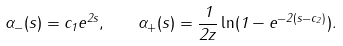<formula> <loc_0><loc_0><loc_500><loc_500>\alpha _ { - } ( s ) = c _ { 1 } e ^ { 2 s } , \quad \alpha _ { + } ( s ) = \frac { 1 } { 2 { z } } \ln ( 1 - e ^ { - 2 ( s - c _ { 2 } ) } ) .</formula> 